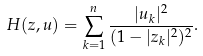Convert formula to latex. <formula><loc_0><loc_0><loc_500><loc_500>H ( z , u ) = \sum _ { k = 1 } ^ { n } \frac { | u _ { k } | ^ { 2 } } { ( 1 - | z _ { k } | ^ { 2 } ) ^ { 2 } } .</formula> 